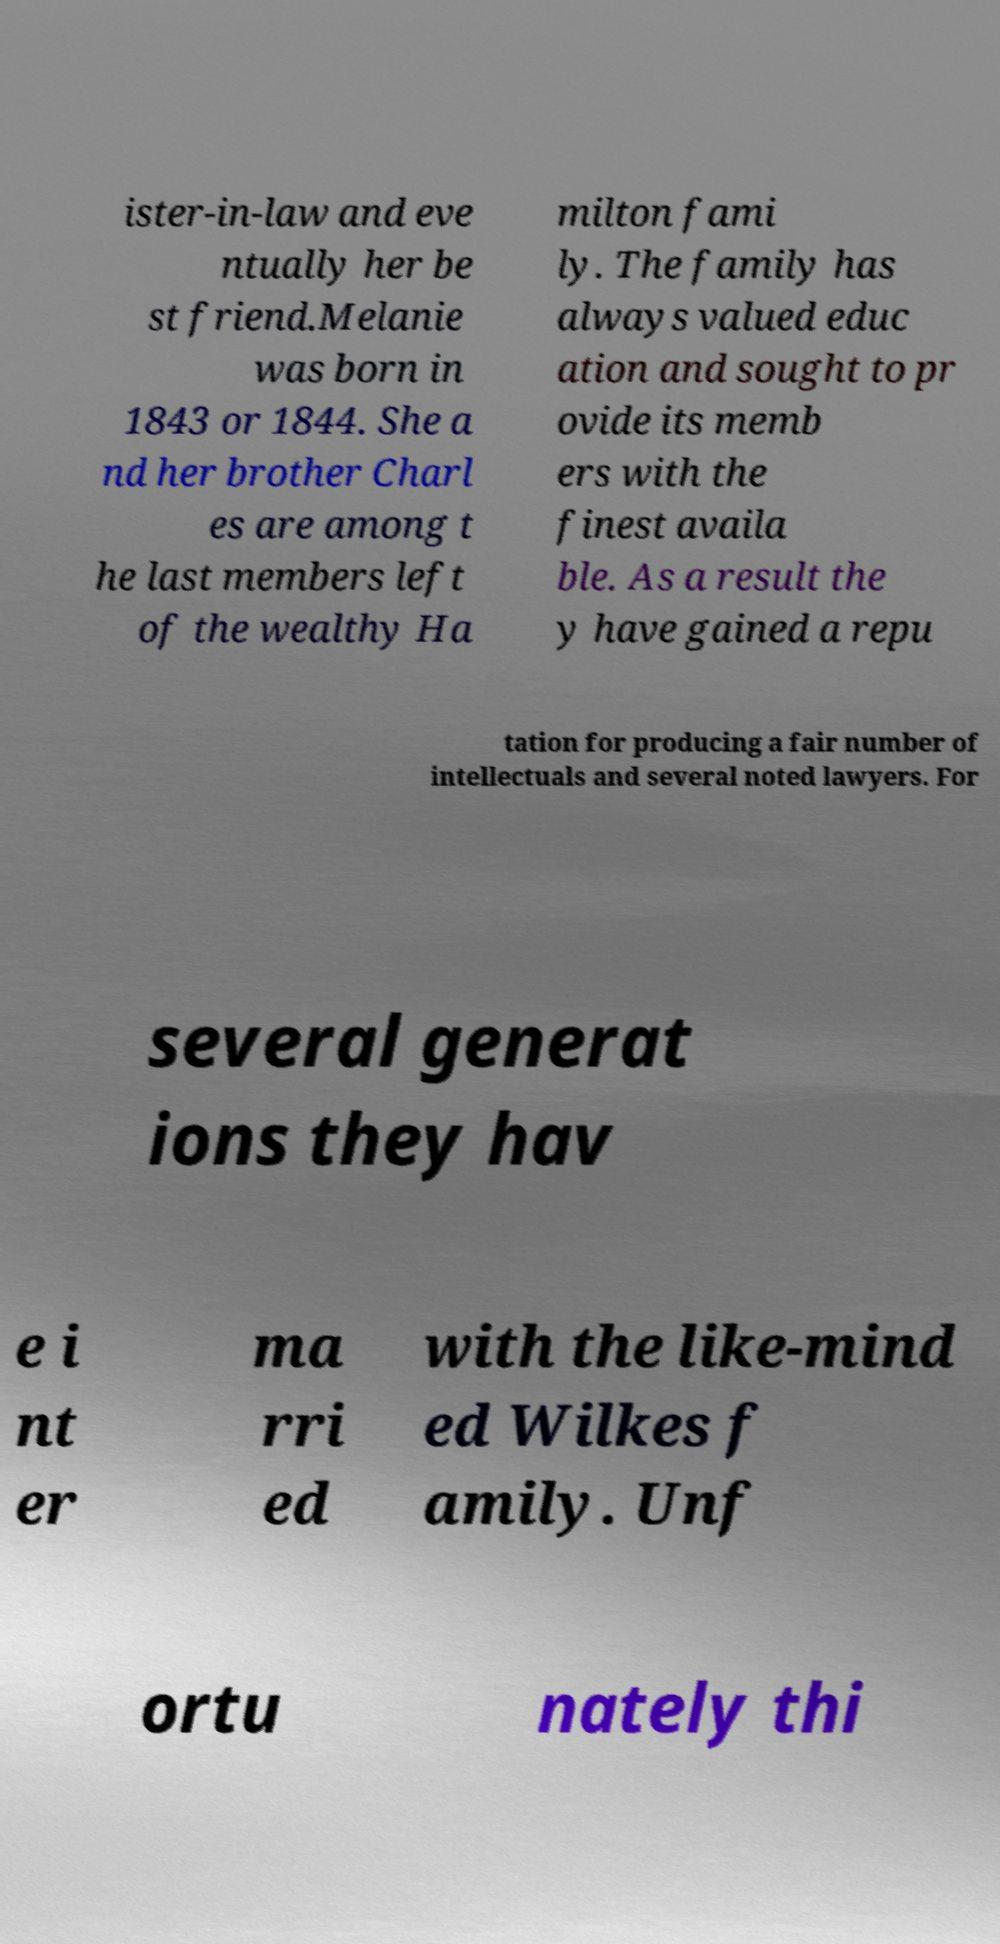Can you read and provide the text displayed in the image?This photo seems to have some interesting text. Can you extract and type it out for me? ister-in-law and eve ntually her be st friend.Melanie was born in 1843 or 1844. She a nd her brother Charl es are among t he last members left of the wealthy Ha milton fami ly. The family has always valued educ ation and sought to pr ovide its memb ers with the finest availa ble. As a result the y have gained a repu tation for producing a fair number of intellectuals and several noted lawyers. For several generat ions they hav e i nt er ma rri ed with the like-mind ed Wilkes f amily. Unf ortu nately thi 